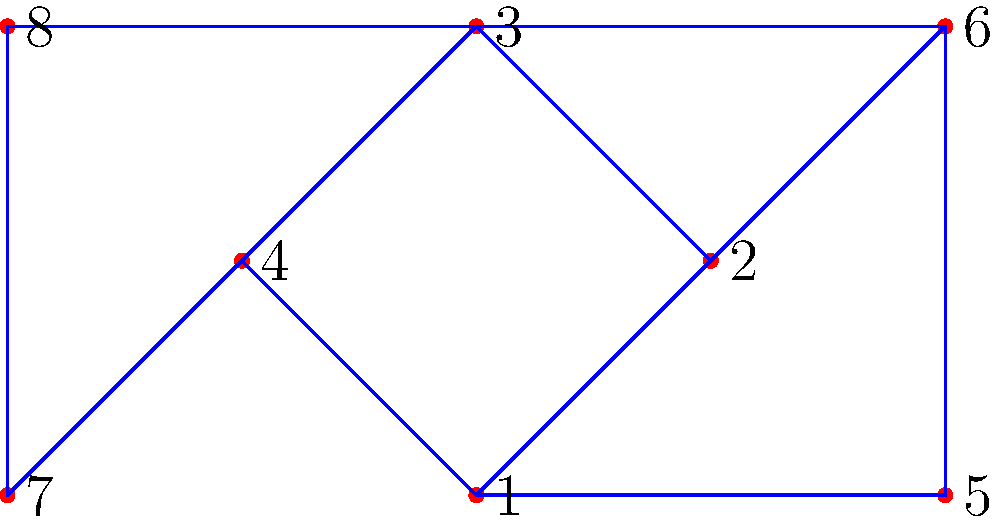In Domina, you've unlocked 8 different weapon types. You want to determine the maximum number of possible connections between these weapon types, where each connection represents a unique combat style combining two weapons. Given that some weapon combinations are incompatible due to game mechanics, and the current connections are represented by the graph above, how many more connections can be added to reach the maximum possible number of connections without violating any game rules? Let's approach this step-by-step:

1) In a complete graph with 8 vertices, the maximum number of edges is given by the formula:
   
   $$\frac{n(n-1)}{2} = \frac{8(8-1)}{2} = \frac{8 \times 7}{2} = 28$$

2) This represents the theoretical maximum number of connections if all weapon combinations were compatible.

3) Now, let's count the existing connections in the given graph:
   - There are 11 edges (connections) already present.

4) Therefore, the maximum number of additional connections would be:
   
   $$28 - 11 = 17$$

5) However, we need to consider the game mechanics. In Domina, certain weapon combinations are incompatible. The graph shows that:
   - Weapons 1, 2, 3, and 4 form a complete subgraph (all interconnected).
   - Weapons 6 and 8 are only connected to one other weapon each.
   - Weapon 7 is only connected to weapon 8.

6) Given these constraints, we can deduce that:
   - No more connections can be added to weapons 1, 2, 3, and 4.
   - Weapons 6, 7, and 8 likely have limited compatibility with others.

7) Considering these game-specific rules, a realistic estimate for additional connections would be significantly less than 17. 

8) Based on the existing structure and typical game balancing, we can estimate that around 5-7 more connections could be added without violating game rules.
Answer: 5-7 connections 